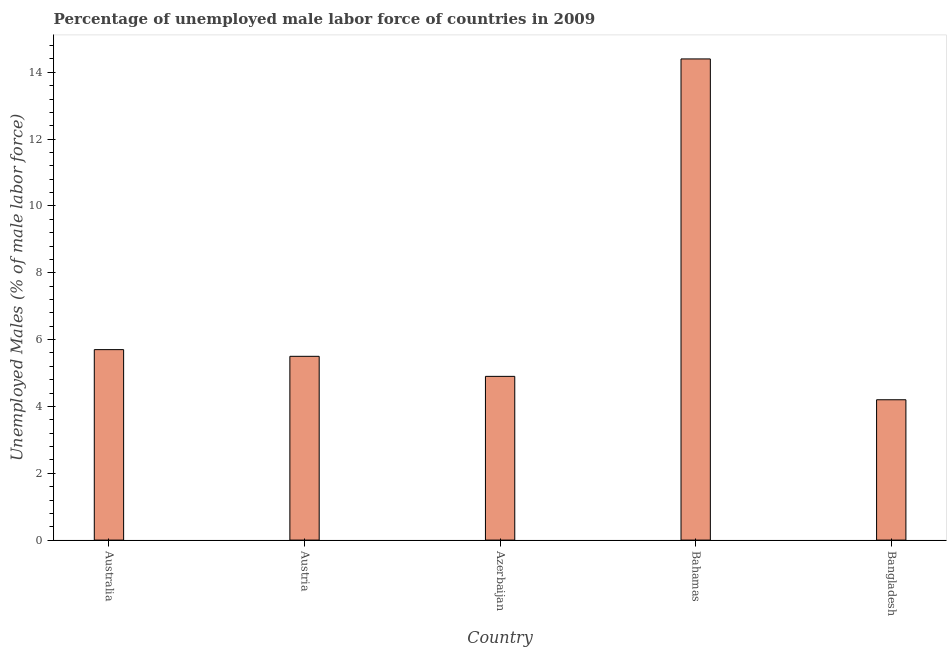Does the graph contain any zero values?
Make the answer very short. No. What is the title of the graph?
Your response must be concise. Percentage of unemployed male labor force of countries in 2009. What is the label or title of the Y-axis?
Provide a succinct answer. Unemployed Males (% of male labor force). What is the total unemployed male labour force in Bahamas?
Give a very brief answer. 14.4. Across all countries, what is the maximum total unemployed male labour force?
Offer a terse response. 14.4. Across all countries, what is the minimum total unemployed male labour force?
Offer a terse response. 4.2. In which country was the total unemployed male labour force maximum?
Your answer should be compact. Bahamas. What is the sum of the total unemployed male labour force?
Offer a very short reply. 34.7. What is the difference between the total unemployed male labour force in Australia and Azerbaijan?
Provide a short and direct response. 0.8. What is the average total unemployed male labour force per country?
Offer a very short reply. 6.94. In how many countries, is the total unemployed male labour force greater than 12 %?
Ensure brevity in your answer.  1. What is the ratio of the total unemployed male labour force in Australia to that in Bahamas?
Give a very brief answer. 0.4. Is the total unemployed male labour force in Austria less than that in Azerbaijan?
Provide a short and direct response. No. Is the difference between the total unemployed male labour force in Australia and Bahamas greater than the difference between any two countries?
Make the answer very short. No. What is the difference between the highest and the lowest total unemployed male labour force?
Provide a short and direct response. 10.2. In how many countries, is the total unemployed male labour force greater than the average total unemployed male labour force taken over all countries?
Give a very brief answer. 1. How many countries are there in the graph?
Offer a terse response. 5. Are the values on the major ticks of Y-axis written in scientific E-notation?
Offer a terse response. No. What is the Unemployed Males (% of male labor force) of Australia?
Ensure brevity in your answer.  5.7. What is the Unemployed Males (% of male labor force) in Austria?
Give a very brief answer. 5.5. What is the Unemployed Males (% of male labor force) of Azerbaijan?
Your answer should be compact. 4.9. What is the Unemployed Males (% of male labor force) of Bahamas?
Your answer should be compact. 14.4. What is the Unemployed Males (% of male labor force) in Bangladesh?
Ensure brevity in your answer.  4.2. What is the difference between the Unemployed Males (% of male labor force) in Australia and Azerbaijan?
Offer a very short reply. 0.8. What is the difference between the Unemployed Males (% of male labor force) in Australia and Bahamas?
Ensure brevity in your answer.  -8.7. What is the difference between the Unemployed Males (% of male labor force) in Australia and Bangladesh?
Your answer should be very brief. 1.5. What is the difference between the Unemployed Males (% of male labor force) in Austria and Azerbaijan?
Offer a very short reply. 0.6. What is the difference between the Unemployed Males (% of male labor force) in Austria and Bahamas?
Offer a terse response. -8.9. What is the difference between the Unemployed Males (% of male labor force) in Austria and Bangladesh?
Your answer should be very brief. 1.3. What is the ratio of the Unemployed Males (% of male labor force) in Australia to that in Austria?
Keep it short and to the point. 1.04. What is the ratio of the Unemployed Males (% of male labor force) in Australia to that in Azerbaijan?
Your answer should be compact. 1.16. What is the ratio of the Unemployed Males (% of male labor force) in Australia to that in Bahamas?
Offer a very short reply. 0.4. What is the ratio of the Unemployed Males (% of male labor force) in Australia to that in Bangladesh?
Make the answer very short. 1.36. What is the ratio of the Unemployed Males (% of male labor force) in Austria to that in Azerbaijan?
Offer a terse response. 1.12. What is the ratio of the Unemployed Males (% of male labor force) in Austria to that in Bahamas?
Offer a terse response. 0.38. What is the ratio of the Unemployed Males (% of male labor force) in Austria to that in Bangladesh?
Offer a very short reply. 1.31. What is the ratio of the Unemployed Males (% of male labor force) in Azerbaijan to that in Bahamas?
Offer a very short reply. 0.34. What is the ratio of the Unemployed Males (% of male labor force) in Azerbaijan to that in Bangladesh?
Keep it short and to the point. 1.17. What is the ratio of the Unemployed Males (% of male labor force) in Bahamas to that in Bangladesh?
Your answer should be very brief. 3.43. 